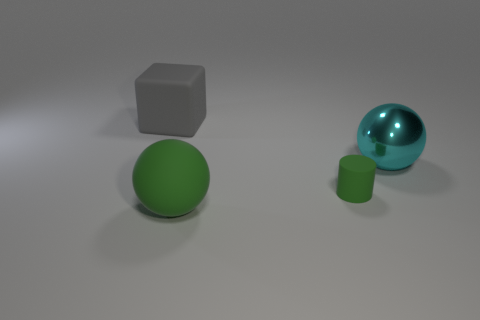Add 4 big gray matte objects. How many objects exist? 8 Subtract all blocks. How many objects are left? 3 Add 4 gray things. How many gray things exist? 5 Subtract 0 blue cylinders. How many objects are left? 4 Subtract all tiny green objects. Subtract all big things. How many objects are left? 0 Add 3 gray blocks. How many gray blocks are left? 4 